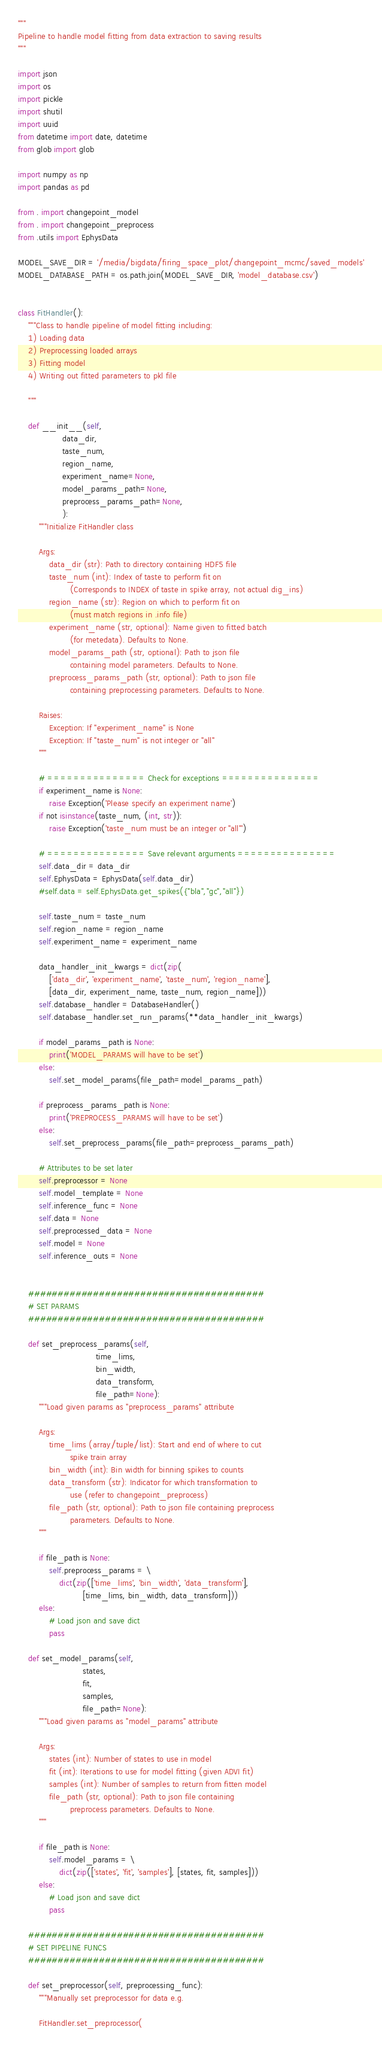<code> <loc_0><loc_0><loc_500><loc_500><_Python_>"""
Pipeline to handle model fitting from data extraction to saving results
"""

import json
import os
import pickle
import shutil
import uuid
from datetime import date, datetime
from glob import glob

import numpy as np
import pandas as pd

from . import changepoint_model
from . import changepoint_preprocess
from .utils import EphysData

MODEL_SAVE_DIR = '/media/bigdata/firing_space_plot/changepoint_mcmc/saved_models'
MODEL_DATABASE_PATH = os.path.join(MODEL_SAVE_DIR, 'model_database.csv')


class FitHandler():
    """Class to handle pipeline of model fitting including:
    1) Loading data
    2) Preprocessing loaded arrays
    3) Fitting model
    4) Writing out fitted parameters to pkl file

    """

    def __init__(self,
                 data_dir,
                 taste_num,
                 region_name,
                 experiment_name=None,
                 model_params_path=None,
                 preprocess_params_path=None,
                 ):
        """Initialize FitHandler class

        Args:
            data_dir (str): Path to directory containing HDF5 file
            taste_num (int): Index of taste to perform fit on
                    (Corresponds to INDEX of taste in spike array, not actual dig_ins)
            region_name (str): Region on which to perform fit on
                    (must match regions in .info file)
            experiment_name (str, optional): Name given to fitted batch
                    (for metedata). Defaults to None.
            model_params_path (str, optional): Path to json file
                    containing model parameters. Defaults to None.
            preprocess_params_path (str, optional): Path to json file
                    containing preprocessing parameters. Defaults to None.

        Raises:
            Exception: If "experiment_name" is None
            Exception: If "taste_num" is not integer or "all"
        """

        # =============== Check for exceptions ===============
        if experiment_name is None:
            raise Exception('Please specify an experiment name')
        if not isinstance(taste_num, (int, str)):
            raise Exception('taste_num must be an integer or "all"')

        # =============== Save relevant arguments ===============
        self.data_dir = data_dir
        self.EphysData = EphysData(self.data_dir)
        #self.data = self.EphysData.get_spikes({"bla","gc","all"})

        self.taste_num = taste_num
        self.region_name = region_name
        self.experiment_name = experiment_name

        data_handler_init_kwargs = dict(zip(
            ['data_dir', 'experiment_name', 'taste_num', 'region_name'],
            [data_dir, experiment_name, taste_num, region_name]))
        self.database_handler = DatabaseHandler()
        self.database_handler.set_run_params(**data_handler_init_kwargs)

        if model_params_path is None:
            print('MODEL_PARAMS will have to be set')
        else:
            self.set_model_params(file_path=model_params_path)

        if preprocess_params_path is None:
            print('PREPROCESS_PARAMS will have to be set')
        else:
            self.set_preprocess_params(file_path=preprocess_params_path)

        # Attributes to be set later
        self.preprocessor = None
        self.model_template = None
        self.inference_func = None
        self.data = None
        self.preprocessed_data = None
        self.model = None
        self.inference_outs = None


    ########################################
    # SET PARAMS
    ########################################

    def set_preprocess_params(self,
                              time_lims,
                              bin_width,
                              data_transform,
                              file_path=None):
        """Load given params as "preprocess_params" attribute

        Args:
            time_lims (array/tuple/list): Start and end of where to cut
                    spike train array
            bin_width (int): Bin width for binning spikes to counts
            data_transform (str): Indicator for which transformation to
                    use (refer to changepoint_preprocess)
            file_path (str, optional): Path to json file containing preprocess
                    parameters. Defaults to None.
        """

        if file_path is None:
            self.preprocess_params = \
                dict(zip(['time_lims', 'bin_width', 'data_transform'],
                         [time_lims, bin_width, data_transform]))
        else:
            # Load json and save dict
            pass

    def set_model_params(self,
                         states,
                         fit,
                         samples,
                         file_path=None):
        """Load given params as "model_params" attribute

        Args:
            states (int): Number of states to use in model
            fit (int): Iterations to use for model fitting (given ADVI fit)
            samples (int): Number of samples to return from fitten model
            file_path (str, optional): Path to json file containing
                    preprocess parameters. Defaults to None.
        """

        if file_path is None:
            self.model_params = \
                dict(zip(['states', 'fit', 'samples'], [states, fit, samples]))
        else:
            # Load json and save dict
            pass

    ########################################
    # SET PIPELINE FUNCS
    ########################################

    def set_preprocessor(self, preprocessing_func):
        """Manually set preprocessor for data e.g.

        FitHandler.set_preprocessor(</code> 